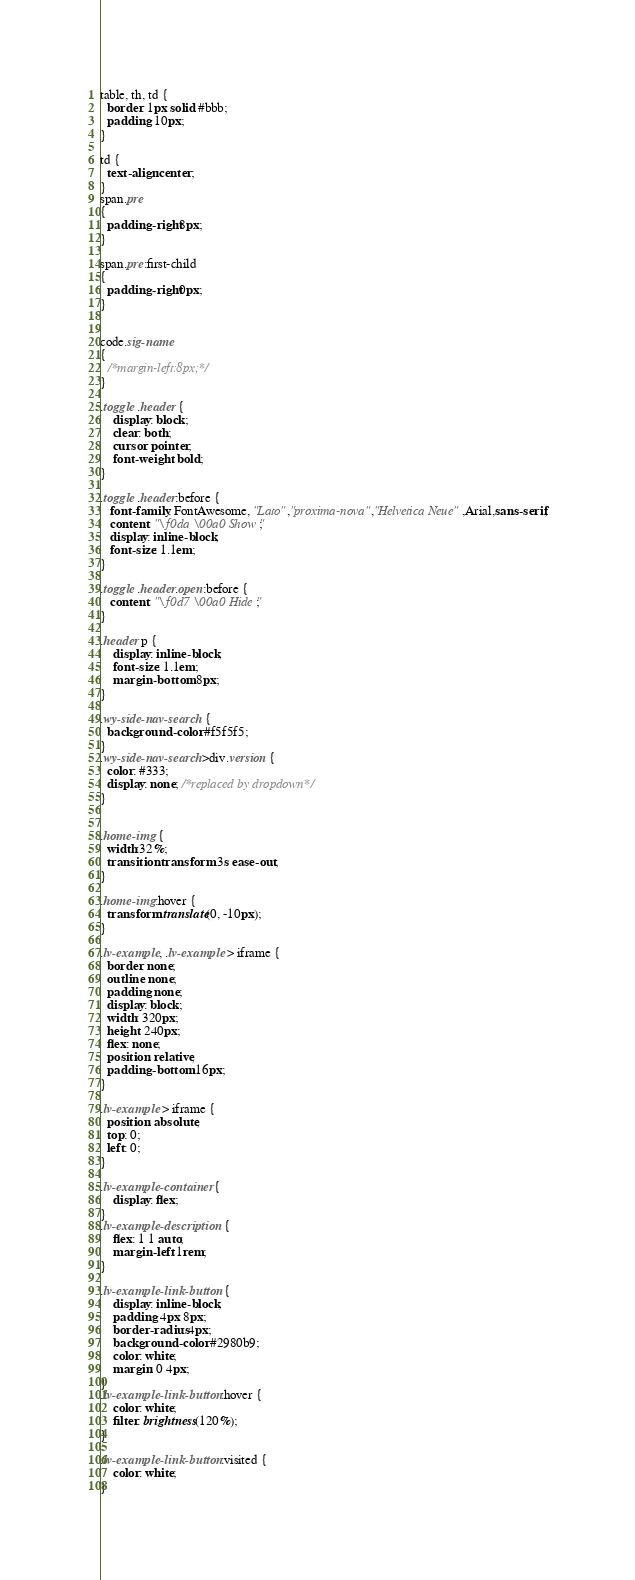<code> <loc_0><loc_0><loc_500><loc_500><_CSS_>table, th, td {
  border: 1px solid #bbb;
  padding: 10px;
}

td {
  text-align:center;
}
span.pre
{  
  padding-right:8px;
}

span.pre:first-child
{  
  padding-right:0px;
}


code.sig-name
{
  /*margin-left:8px;*/
}

.toggle .header {
    display: block;
    clear: both;
    cursor: pointer;
    font-weight: bold; 
}

.toggle .header:before {
   font-family: FontAwesome, "Lato","proxima-nova","Helvetica Neue",Arial,sans-serif;
   content: "\f0da \00a0 Show "; 
   display: inline-block;
   font-size: 1.1em;
}

.toggle .header.open:before {
   content: "\f0d7 \00a0 Hide "; 
}

.header p {
    display: inline-block;
    font-size: 1.1em;
    margin-bottom: 8px;
}

.wy-side-nav-search {
  background-color: #f5f5f5;
}
.wy-side-nav-search>div.version {
  color: #333;
  display: none; /*replaced by dropdown*/
}


.home-img {
  width:32%; 
  transition: transform .3s ease-out;
}

.home-img:hover {
  transform: translate(0, -10px);
}

.lv-example, .lv-example > iframe {
  border: none;
  outline: none;
  padding: none;
  display: block;
  width: 320px;
  height: 240px;
  flex: none;
  position: relative;
  padding-bottom: 16px;
}

.lv-example > iframe {
  position: absolute;
  top: 0;
  left: 0;
}

.lv-example-container {
    display: flex;
}
.lv-example-description {
    flex: 1 1 auto;
    margin-left: 1rem;
}

.lv-example-link-button {
    display: inline-block;
    padding: 4px 8px;
    border-radius: 4px;
    background-color: #2980b9;
    color: white;
    margin: 0 4px;
}
.lv-example-link-button:hover {
    color: white;
    filter: brightness(120%);
}

.lv-example-link-button:visited {
    color: white;
}
</code> 